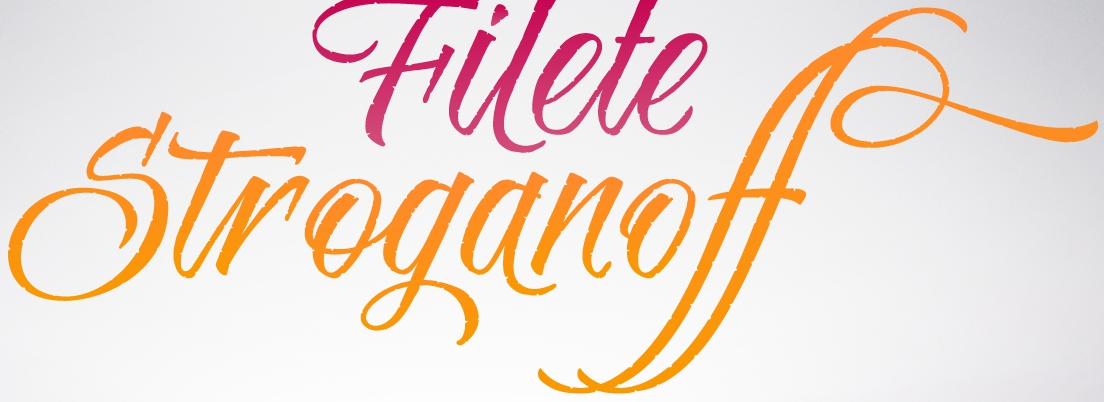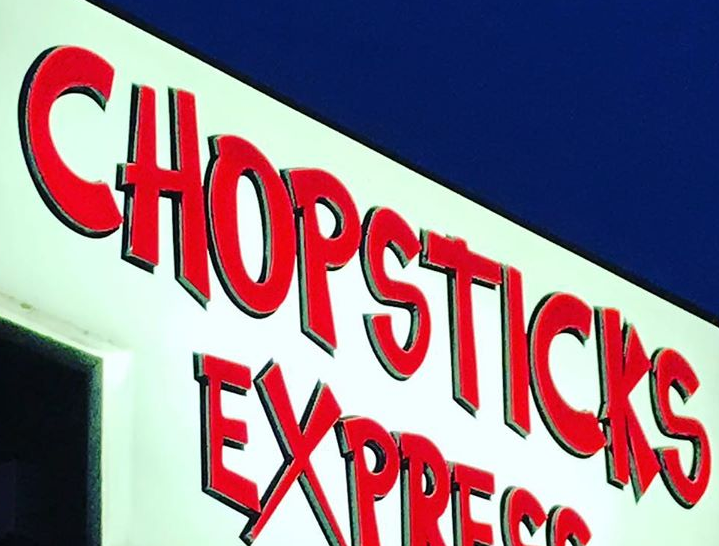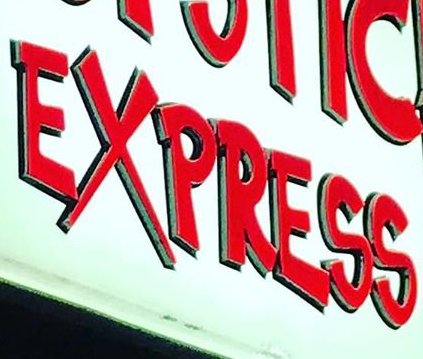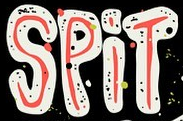What text is displayed in these images sequentially, separated by a semicolon? Stroganoff; CHOPSTICKS; EXPRESS; SPiT 